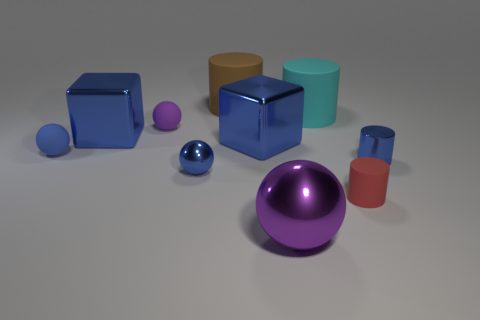Subtract 1 cylinders. How many cylinders are left? 3 Subtract all cubes. How many objects are left? 8 Subtract all blue matte balls. Subtract all big yellow cylinders. How many objects are left? 9 Add 1 brown matte objects. How many brown matte objects are left? 2 Add 2 purple things. How many purple things exist? 4 Subtract 0 red cubes. How many objects are left? 10 